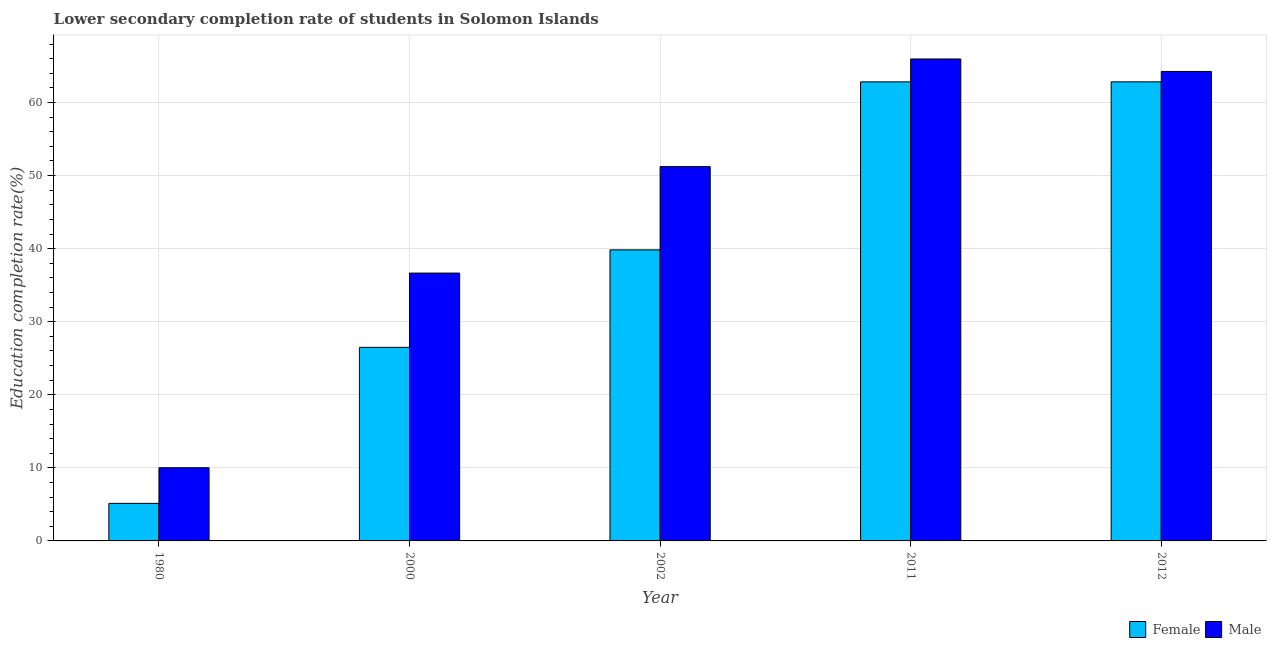How many groups of bars are there?
Give a very brief answer. 5. Are the number of bars per tick equal to the number of legend labels?
Keep it short and to the point. Yes. How many bars are there on the 2nd tick from the right?
Give a very brief answer. 2. What is the education completion rate of male students in 2012?
Provide a succinct answer. 64.26. Across all years, what is the maximum education completion rate of female students?
Make the answer very short. 62.83. Across all years, what is the minimum education completion rate of female students?
Your response must be concise. 5.14. What is the total education completion rate of male students in the graph?
Your answer should be very brief. 228.12. What is the difference between the education completion rate of male students in 1980 and that in 2012?
Provide a succinct answer. -54.24. What is the difference between the education completion rate of female students in 1980 and the education completion rate of male students in 2012?
Make the answer very short. -57.69. What is the average education completion rate of male students per year?
Provide a succinct answer. 45.62. In the year 2002, what is the difference between the education completion rate of female students and education completion rate of male students?
Your answer should be compact. 0. What is the ratio of the education completion rate of female students in 2011 to that in 2012?
Provide a short and direct response. 1. Is the education completion rate of male students in 2002 less than that in 2012?
Provide a short and direct response. Yes. Is the difference between the education completion rate of male students in 1980 and 2012 greater than the difference between the education completion rate of female students in 1980 and 2012?
Make the answer very short. No. What is the difference between the highest and the second highest education completion rate of male students?
Keep it short and to the point. 1.71. What is the difference between the highest and the lowest education completion rate of female students?
Your answer should be compact. 57.69. Is the sum of the education completion rate of male students in 2000 and 2012 greater than the maximum education completion rate of female students across all years?
Keep it short and to the point. Yes. What does the 2nd bar from the left in 1980 represents?
Provide a succinct answer. Male. What does the 2nd bar from the right in 1980 represents?
Offer a terse response. Female. How many bars are there?
Provide a short and direct response. 10. Are all the bars in the graph horizontal?
Provide a succinct answer. No. How many years are there in the graph?
Your answer should be very brief. 5. What is the difference between two consecutive major ticks on the Y-axis?
Your answer should be compact. 10. Does the graph contain any zero values?
Offer a very short reply. No. Where does the legend appear in the graph?
Provide a succinct answer. Bottom right. How are the legend labels stacked?
Give a very brief answer. Horizontal. What is the title of the graph?
Keep it short and to the point. Lower secondary completion rate of students in Solomon Islands. What is the label or title of the X-axis?
Your answer should be compact. Year. What is the label or title of the Y-axis?
Make the answer very short. Education completion rate(%). What is the Education completion rate(%) in Female in 1980?
Keep it short and to the point. 5.14. What is the Education completion rate(%) of Male in 1980?
Provide a succinct answer. 10.02. What is the Education completion rate(%) in Female in 2000?
Your answer should be very brief. 26.5. What is the Education completion rate(%) in Male in 2000?
Keep it short and to the point. 36.66. What is the Education completion rate(%) of Female in 2002?
Your response must be concise. 39.83. What is the Education completion rate(%) of Male in 2002?
Provide a succinct answer. 51.22. What is the Education completion rate(%) in Female in 2011?
Your response must be concise. 62.83. What is the Education completion rate(%) of Male in 2011?
Your answer should be very brief. 65.96. What is the Education completion rate(%) in Female in 2012?
Your answer should be compact. 62.83. What is the Education completion rate(%) in Male in 2012?
Offer a terse response. 64.26. Across all years, what is the maximum Education completion rate(%) in Female?
Offer a terse response. 62.83. Across all years, what is the maximum Education completion rate(%) of Male?
Offer a very short reply. 65.96. Across all years, what is the minimum Education completion rate(%) of Female?
Ensure brevity in your answer.  5.14. Across all years, what is the minimum Education completion rate(%) of Male?
Your answer should be compact. 10.02. What is the total Education completion rate(%) in Female in the graph?
Make the answer very short. 197.13. What is the total Education completion rate(%) of Male in the graph?
Give a very brief answer. 228.12. What is the difference between the Education completion rate(%) in Female in 1980 and that in 2000?
Offer a very short reply. -21.36. What is the difference between the Education completion rate(%) in Male in 1980 and that in 2000?
Offer a very short reply. -26.64. What is the difference between the Education completion rate(%) of Female in 1980 and that in 2002?
Offer a very short reply. -34.7. What is the difference between the Education completion rate(%) of Male in 1980 and that in 2002?
Offer a very short reply. -41.2. What is the difference between the Education completion rate(%) of Female in 1980 and that in 2011?
Your answer should be compact. -57.69. What is the difference between the Education completion rate(%) in Male in 1980 and that in 2011?
Make the answer very short. -55.94. What is the difference between the Education completion rate(%) in Female in 1980 and that in 2012?
Make the answer very short. -57.69. What is the difference between the Education completion rate(%) in Male in 1980 and that in 2012?
Your answer should be compact. -54.24. What is the difference between the Education completion rate(%) of Female in 2000 and that in 2002?
Make the answer very short. -13.34. What is the difference between the Education completion rate(%) in Male in 2000 and that in 2002?
Your response must be concise. -14.57. What is the difference between the Education completion rate(%) in Female in 2000 and that in 2011?
Your response must be concise. -36.33. What is the difference between the Education completion rate(%) in Male in 2000 and that in 2011?
Provide a succinct answer. -29.3. What is the difference between the Education completion rate(%) of Female in 2000 and that in 2012?
Offer a terse response. -36.34. What is the difference between the Education completion rate(%) in Male in 2000 and that in 2012?
Make the answer very short. -27.6. What is the difference between the Education completion rate(%) in Female in 2002 and that in 2011?
Your answer should be compact. -22.99. What is the difference between the Education completion rate(%) of Male in 2002 and that in 2011?
Keep it short and to the point. -14.74. What is the difference between the Education completion rate(%) in Female in 2002 and that in 2012?
Make the answer very short. -23. What is the difference between the Education completion rate(%) of Male in 2002 and that in 2012?
Your answer should be very brief. -13.03. What is the difference between the Education completion rate(%) in Female in 2011 and that in 2012?
Provide a succinct answer. -0. What is the difference between the Education completion rate(%) of Male in 2011 and that in 2012?
Your response must be concise. 1.71. What is the difference between the Education completion rate(%) of Female in 1980 and the Education completion rate(%) of Male in 2000?
Make the answer very short. -31.52. What is the difference between the Education completion rate(%) in Female in 1980 and the Education completion rate(%) in Male in 2002?
Your answer should be very brief. -46.09. What is the difference between the Education completion rate(%) in Female in 1980 and the Education completion rate(%) in Male in 2011?
Offer a terse response. -60.82. What is the difference between the Education completion rate(%) of Female in 1980 and the Education completion rate(%) of Male in 2012?
Give a very brief answer. -59.12. What is the difference between the Education completion rate(%) in Female in 2000 and the Education completion rate(%) in Male in 2002?
Provide a succinct answer. -24.73. What is the difference between the Education completion rate(%) in Female in 2000 and the Education completion rate(%) in Male in 2011?
Your answer should be very brief. -39.47. What is the difference between the Education completion rate(%) of Female in 2000 and the Education completion rate(%) of Male in 2012?
Make the answer very short. -37.76. What is the difference between the Education completion rate(%) in Female in 2002 and the Education completion rate(%) in Male in 2011?
Ensure brevity in your answer.  -26.13. What is the difference between the Education completion rate(%) in Female in 2002 and the Education completion rate(%) in Male in 2012?
Provide a succinct answer. -24.42. What is the difference between the Education completion rate(%) of Female in 2011 and the Education completion rate(%) of Male in 2012?
Your response must be concise. -1.43. What is the average Education completion rate(%) of Female per year?
Give a very brief answer. 39.43. What is the average Education completion rate(%) in Male per year?
Make the answer very short. 45.62. In the year 1980, what is the difference between the Education completion rate(%) in Female and Education completion rate(%) in Male?
Make the answer very short. -4.88. In the year 2000, what is the difference between the Education completion rate(%) in Female and Education completion rate(%) in Male?
Offer a very short reply. -10.16. In the year 2002, what is the difference between the Education completion rate(%) of Female and Education completion rate(%) of Male?
Ensure brevity in your answer.  -11.39. In the year 2011, what is the difference between the Education completion rate(%) of Female and Education completion rate(%) of Male?
Keep it short and to the point. -3.13. In the year 2012, what is the difference between the Education completion rate(%) in Female and Education completion rate(%) in Male?
Ensure brevity in your answer.  -1.42. What is the ratio of the Education completion rate(%) in Female in 1980 to that in 2000?
Give a very brief answer. 0.19. What is the ratio of the Education completion rate(%) of Male in 1980 to that in 2000?
Offer a very short reply. 0.27. What is the ratio of the Education completion rate(%) of Female in 1980 to that in 2002?
Offer a terse response. 0.13. What is the ratio of the Education completion rate(%) in Male in 1980 to that in 2002?
Your answer should be very brief. 0.2. What is the ratio of the Education completion rate(%) of Female in 1980 to that in 2011?
Provide a short and direct response. 0.08. What is the ratio of the Education completion rate(%) in Male in 1980 to that in 2011?
Offer a terse response. 0.15. What is the ratio of the Education completion rate(%) in Female in 1980 to that in 2012?
Offer a terse response. 0.08. What is the ratio of the Education completion rate(%) of Male in 1980 to that in 2012?
Your answer should be compact. 0.16. What is the ratio of the Education completion rate(%) of Female in 2000 to that in 2002?
Offer a terse response. 0.67. What is the ratio of the Education completion rate(%) in Male in 2000 to that in 2002?
Your answer should be very brief. 0.72. What is the ratio of the Education completion rate(%) in Female in 2000 to that in 2011?
Your response must be concise. 0.42. What is the ratio of the Education completion rate(%) in Male in 2000 to that in 2011?
Give a very brief answer. 0.56. What is the ratio of the Education completion rate(%) of Female in 2000 to that in 2012?
Provide a short and direct response. 0.42. What is the ratio of the Education completion rate(%) of Male in 2000 to that in 2012?
Your response must be concise. 0.57. What is the ratio of the Education completion rate(%) in Female in 2002 to that in 2011?
Offer a terse response. 0.63. What is the ratio of the Education completion rate(%) in Male in 2002 to that in 2011?
Keep it short and to the point. 0.78. What is the ratio of the Education completion rate(%) in Female in 2002 to that in 2012?
Ensure brevity in your answer.  0.63. What is the ratio of the Education completion rate(%) in Male in 2002 to that in 2012?
Your answer should be compact. 0.8. What is the ratio of the Education completion rate(%) of Female in 2011 to that in 2012?
Your answer should be compact. 1. What is the ratio of the Education completion rate(%) in Male in 2011 to that in 2012?
Provide a succinct answer. 1.03. What is the difference between the highest and the second highest Education completion rate(%) of Female?
Your answer should be very brief. 0. What is the difference between the highest and the second highest Education completion rate(%) in Male?
Keep it short and to the point. 1.71. What is the difference between the highest and the lowest Education completion rate(%) in Female?
Your answer should be very brief. 57.69. What is the difference between the highest and the lowest Education completion rate(%) of Male?
Make the answer very short. 55.94. 